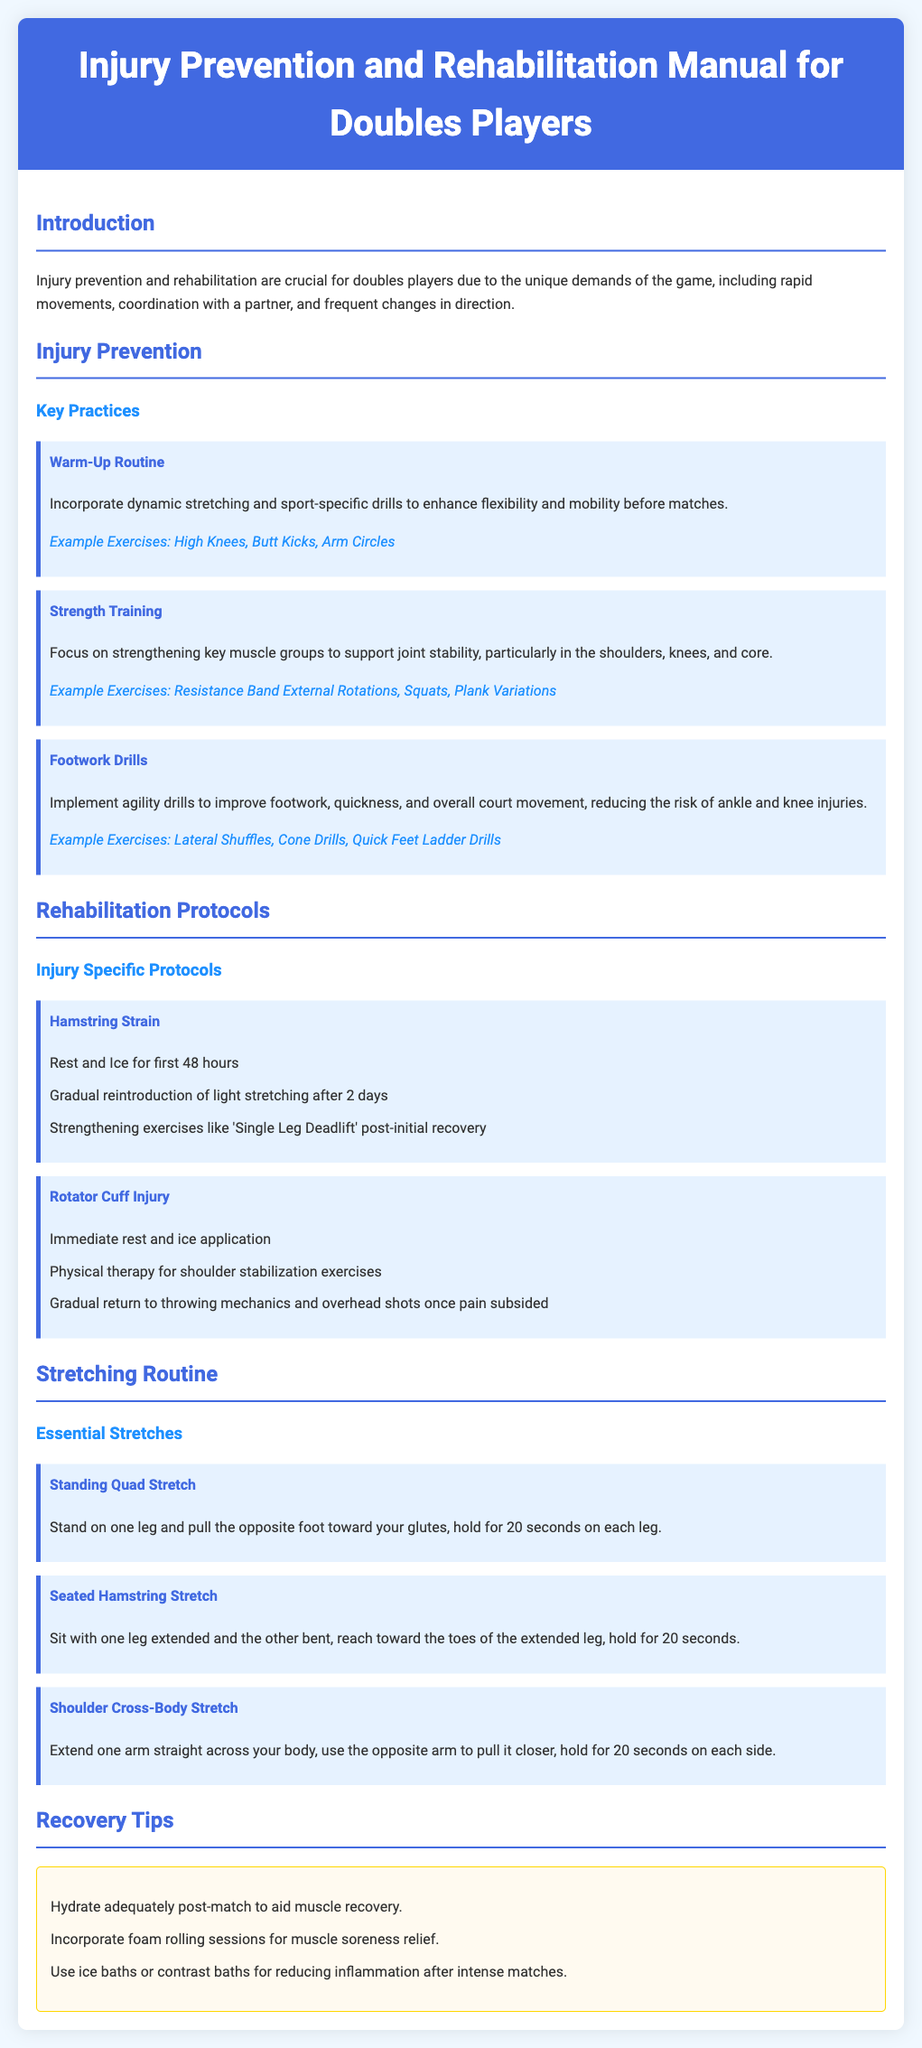what is the title of the manual? The title of the manual is provided in the header section of the document.
Answer: Injury Prevention and Rehabilitation Manual for Doubles Players what section discusses key practices for injury prevention? The section dedicated to injury prevention practices is specified in the main content.
Answer: Injury Prevention what exercise helps improve footwork? The document lists exercises for footwork improvement in a specific section.
Answer: Lateral Shuffles how long should you hold the Standing Quad Stretch? The duration for holding the stretch is mentioned in the description of the exercise.
Answer: 20 seconds what is the first step in the rehabilitation protocol for a hamstring strain? The initial step for hamstring strain rehabilitation is outlined in the protocols section.
Answer: Rest and Ice for first 48 hours name one recovery tip provided in the manual. Recovery tips are listed in a dedicated section, highlighting various strategies.
Answer: Hydrate adequately post-match which injury requires physical therapy according to the document? The specific injury that mentions the need for physical therapy is discussed in the rehabilitation protocols.
Answer: Rotator Cuff Injury what type of routine should be incorporated before matches? The manual specifies a type of routine that is important for performance before matches.
Answer: Warm-Up Routine 